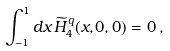<formula> <loc_0><loc_0><loc_500><loc_500>\int _ { - 1 } ^ { 1 } d x \, \widetilde { H } _ { 4 } ^ { q } ( x , 0 , 0 ) = 0 \, ,</formula> 